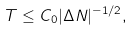Convert formula to latex. <formula><loc_0><loc_0><loc_500><loc_500>T \leq C _ { 0 } | \Delta N | ^ { - 1 / 2 } ,</formula> 